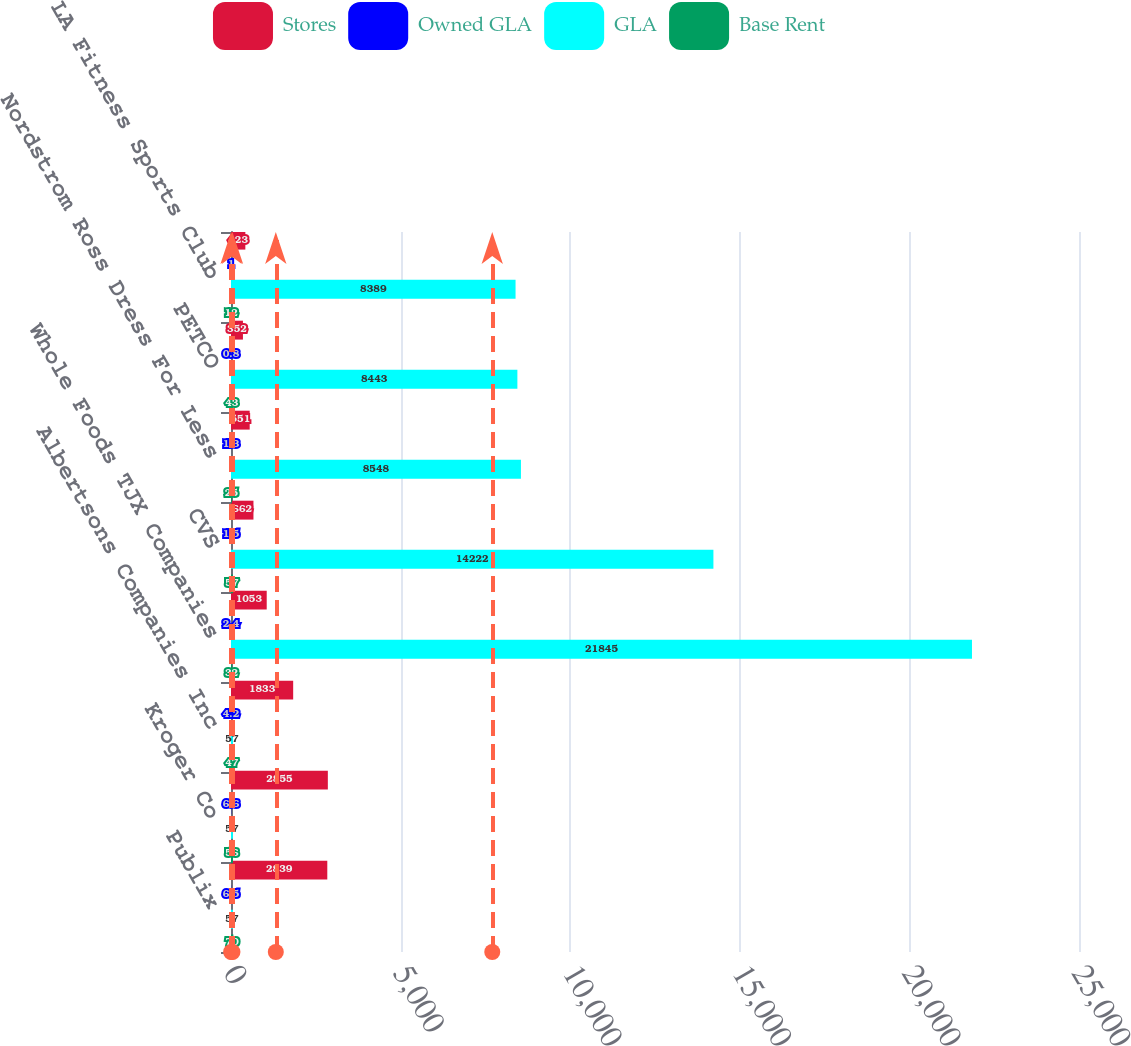<chart> <loc_0><loc_0><loc_500><loc_500><stacked_bar_chart><ecel><fcel>Publix<fcel>Kroger Co<fcel>Albertsons Companies Inc<fcel>Whole Foods TJX Companies<fcel>CVS<fcel>Nordstrom Ross Dress For Less<fcel>PETCO<fcel>LA Fitness Sports Club<nl><fcel>Stores<fcel>2839<fcel>2855<fcel>1833<fcel>1053<fcel>662<fcel>551<fcel>352<fcel>423<nl><fcel>Owned GLA<fcel>6.5<fcel>6.6<fcel>4.2<fcel>2.4<fcel>1.5<fcel>1.3<fcel>0.8<fcel>1<nl><fcel>GLA<fcel>57<fcel>57<fcel>57<fcel>21845<fcel>14222<fcel>8548<fcel>8443<fcel>8389<nl><fcel>Base Rent<fcel>70<fcel>56<fcel>47<fcel>32<fcel>57<fcel>25<fcel>43<fcel>12<nl></chart> 